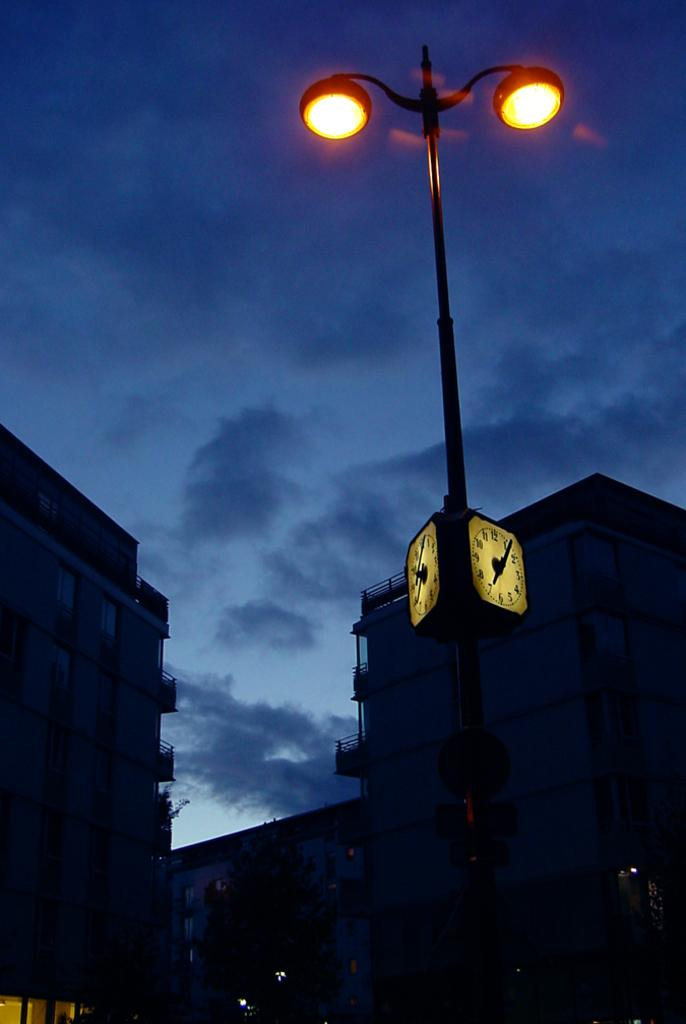What type of lighting is present in the image? There are street lights in the image. What other time-related objects can be seen in the image? There are clocks on a pole in the image. What type of vegetation is present in the image? There is a tree in the image. What type of structures are present in the image? There are buildings in the image. What other objects can be seen in the image besides street lights, clocks, trees, and buildings? There are other objects in the image. What is the weather like in the image? The sky is cloudy in the image. Can you see a cow being crushed by a home in the image? No, there is no cow or home being crushed in the image. 